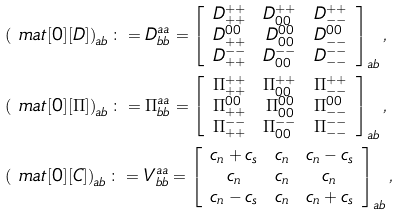Convert formula to latex. <formula><loc_0><loc_0><loc_500><loc_500>& \left ( \ m a t [ 0 ] [ D ] \right ) _ { a b } \colon = D ^ { a a } _ { b b } = \left [ \begin{array} { c c c } D ^ { + + } _ { + + } & D ^ { + + } _ { 0 0 } & D ^ { + + } _ { - - } \\ D ^ { 0 0 } _ { + + } & D ^ { 0 0 } _ { 0 0 } & D ^ { 0 0 } _ { - - } \\ D ^ { - - } _ { + + } & D ^ { - - } _ { 0 0 } & D ^ { - - } _ { - - } \end{array} \right ] _ { a b } , \\ & \left ( \ m a t [ 0 ] [ \Pi ] \right ) _ { a b } \colon = \Pi ^ { a a } _ { b b } = \left [ \begin{array} { c c c } \Pi ^ { + + } _ { + + } & \Pi ^ { + + } _ { 0 0 } & \Pi ^ { + + } _ { - - } \\ \Pi ^ { 0 0 } _ { + + } & \Pi ^ { 0 0 } _ { 0 0 } & \Pi ^ { 0 0 } _ { - - } \\ \Pi ^ { - - } _ { + + } & \Pi ^ { - - } _ { 0 0 } & \Pi ^ { - - } _ { - - } \end{array} \right ] _ { a b } , \\ & \left ( \ m a t [ 0 ] [ C ] \right ) _ { a b } \colon = V ^ { a a } _ { b b } = \left [ \begin{array} { c c c } c _ { n } + c _ { s } & c _ { n } & c _ { n } - c _ { s } \\ c _ { n } & c _ { n } & c _ { n } \\ c _ { n } - c _ { s } & c _ { n } & c _ { n } + c _ { s } \end{array} \right ] _ { a b } ,</formula> 